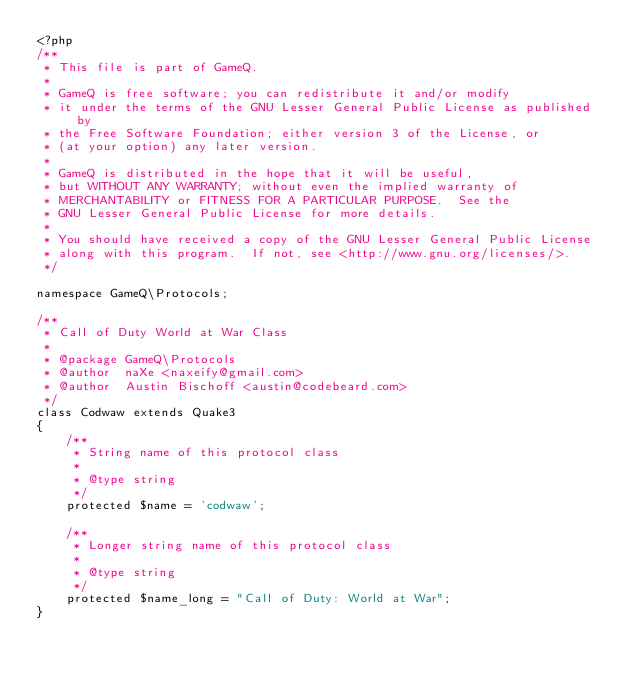Convert code to text. <code><loc_0><loc_0><loc_500><loc_500><_PHP_><?php
/**
 * This file is part of GameQ.
 *
 * GameQ is free software; you can redistribute it and/or modify
 * it under the terms of the GNU Lesser General Public License as published by
 * the Free Software Foundation; either version 3 of the License, or
 * (at your option) any later version.
 *
 * GameQ is distributed in the hope that it will be useful,
 * but WITHOUT ANY WARRANTY; without even the implied warranty of
 * MERCHANTABILITY or FITNESS FOR A PARTICULAR PURPOSE.  See the
 * GNU Lesser General Public License for more details.
 *
 * You should have received a copy of the GNU Lesser General Public License
 * along with this program.  If not, see <http://www.gnu.org/licenses/>.
 */

namespace GameQ\Protocols;

/**
 * Call of Duty World at War Class
 *
 * @package GameQ\Protocols
 * @author  naXe <naxeify@gmail.com>
 * @author  Austin Bischoff <austin@codebeard.com>
 */
class Codwaw extends Quake3
{
    /**
     * String name of this protocol class
     *
     * @type string
     */
    protected $name = 'codwaw';

    /**
     * Longer string name of this protocol class
     *
     * @type string
     */
    protected $name_long = "Call of Duty: World at War";
}
</code> 